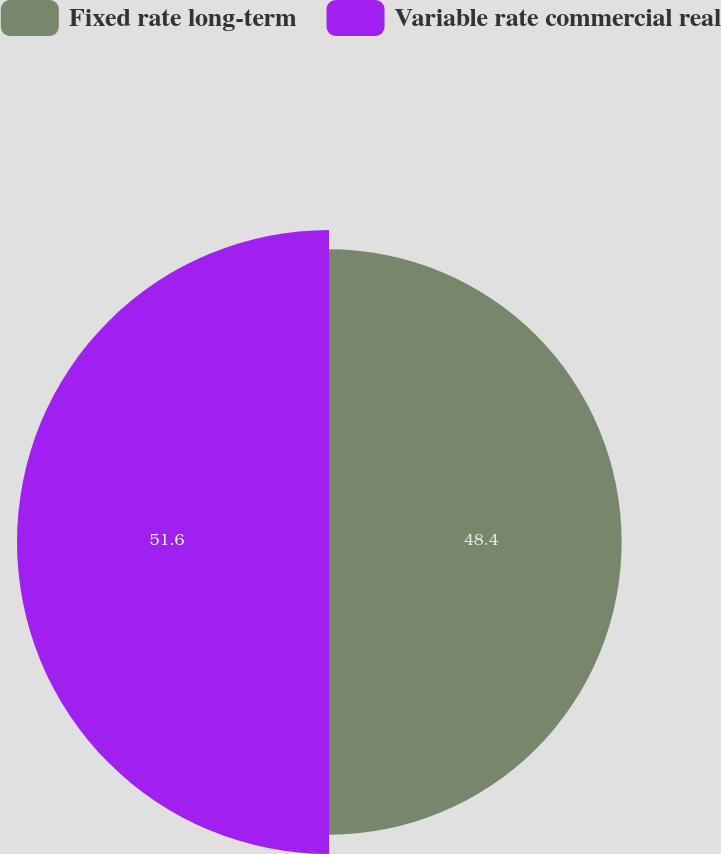Convert chart. <chart><loc_0><loc_0><loc_500><loc_500><pie_chart><fcel>Fixed rate long-term<fcel>Variable rate commercial real<nl><fcel>48.4%<fcel>51.6%<nl></chart> 